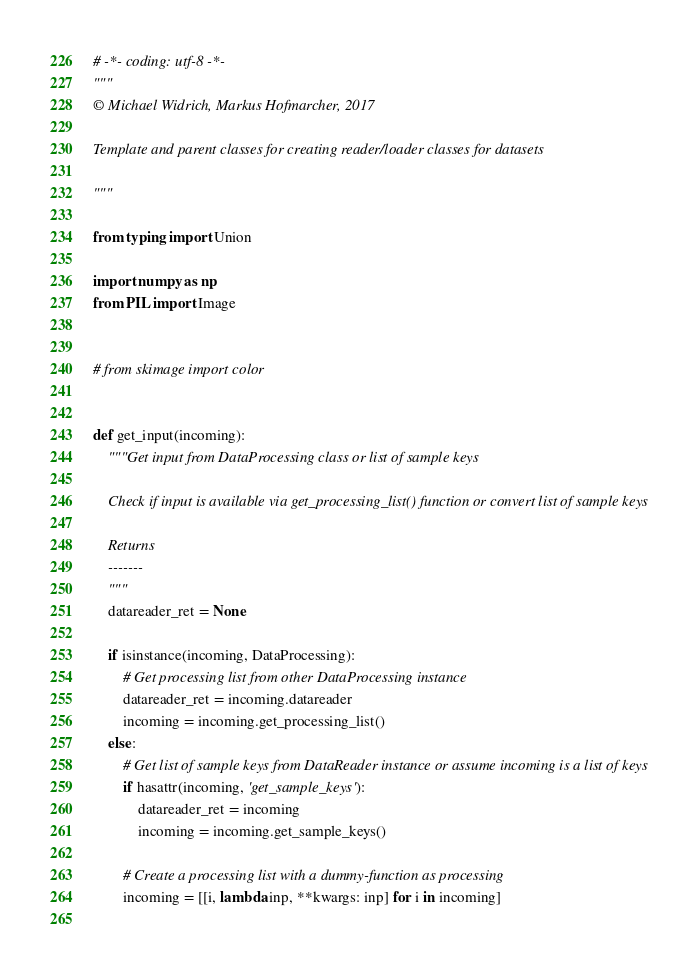<code> <loc_0><loc_0><loc_500><loc_500><_Python_># -*- coding: utf-8 -*-
"""
© Michael Widrich, Markus Hofmarcher, 2017

Template and parent classes for creating reader/loader classes for datasets

"""

from typing import Union

import numpy as np
from PIL import Image


# from skimage import color


def get_input(incoming):
    """Get input from DataProcessing class or list of sample keys

    Check if input is available via get_processing_list() function or convert list of sample keys

    Returns
    -------
    """
    datareader_ret = None
    
    if isinstance(incoming, DataProcessing):
        # Get processing list from other DataProcessing instance
        datareader_ret = incoming.datareader
        incoming = incoming.get_processing_list()
    else:
        # Get list of sample keys from DataReader instance or assume incoming is a list of keys
        if hasattr(incoming, 'get_sample_keys'):
            datareader_ret = incoming
            incoming = incoming.get_sample_keys()
        
        # Create a processing list with a dummy-function as processing
        incoming = [[i, lambda inp, **kwargs: inp] for i in incoming]
    </code> 